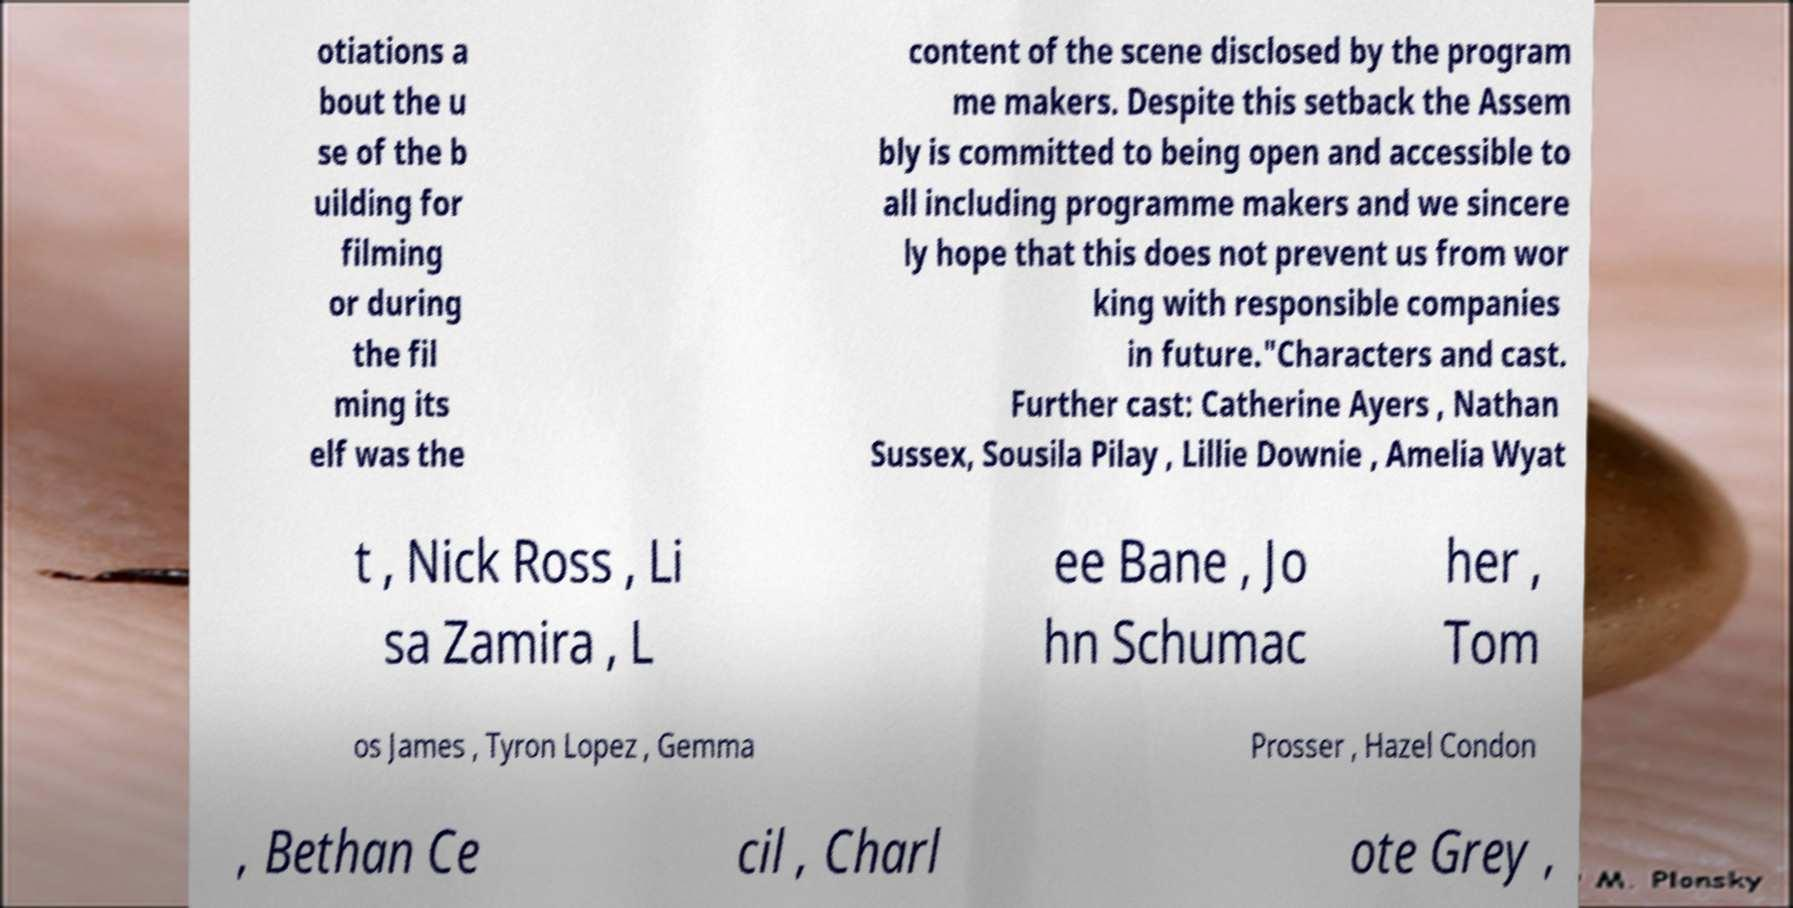Could you extract and type out the text from this image? otiations a bout the u se of the b uilding for filming or during the fil ming its elf was the content of the scene disclosed by the program me makers. Despite this setback the Assem bly is committed to being open and accessible to all including programme makers and we sincere ly hope that this does not prevent us from wor king with responsible companies in future."Characters and cast. Further cast: Catherine Ayers , Nathan Sussex, Sousila Pilay , Lillie Downie , Amelia Wyat t , Nick Ross , Li sa Zamira , L ee Bane , Jo hn Schumac her , Tom os James , Tyron Lopez , Gemma Prosser , Hazel Condon , Bethan Ce cil , Charl ote Grey , 